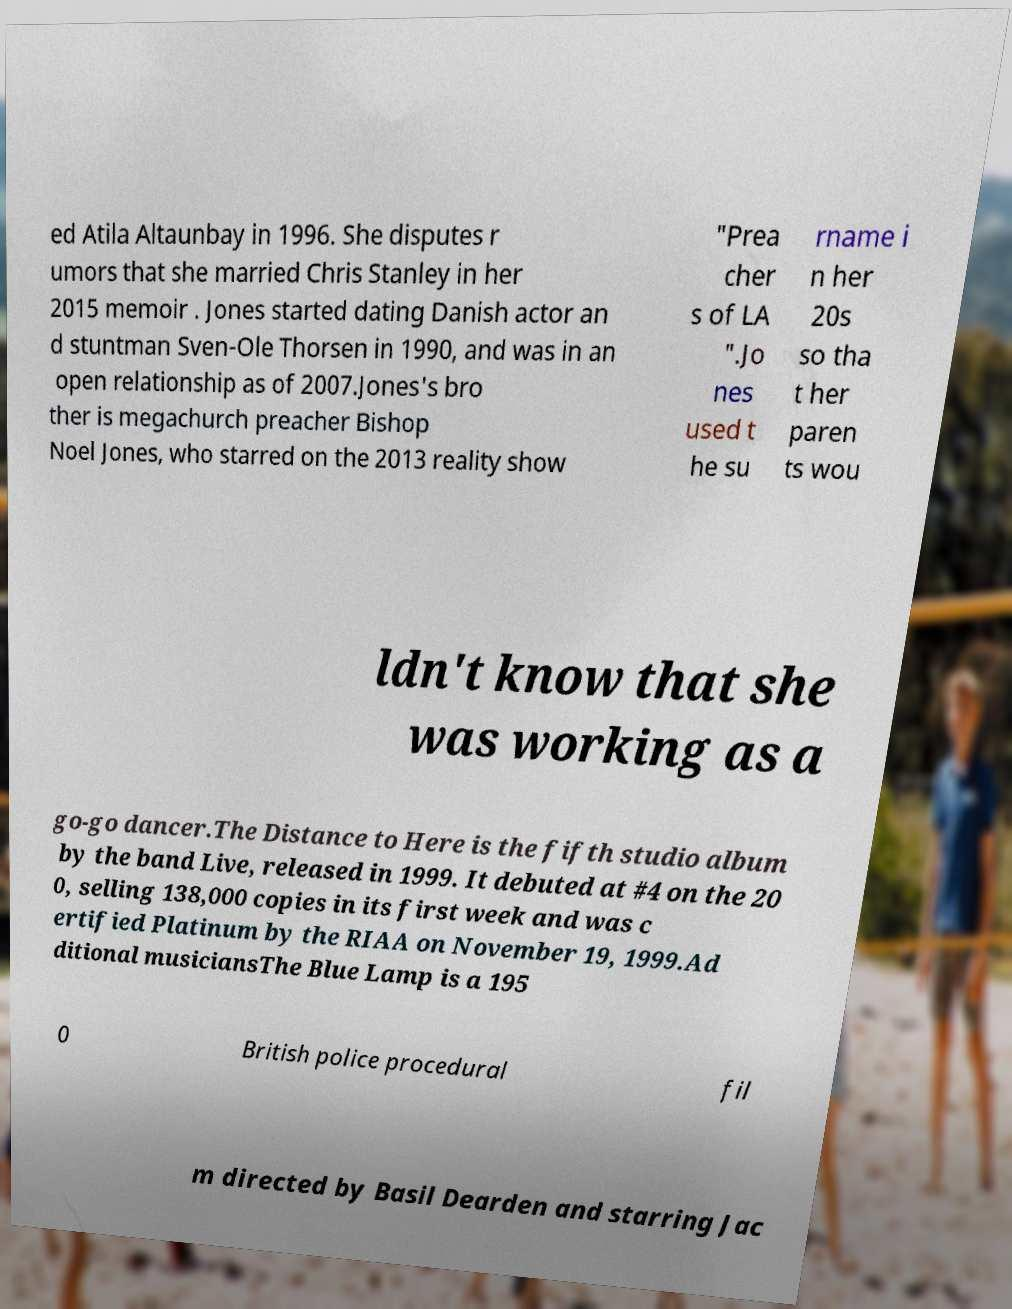Please identify and transcribe the text found in this image. ed Atila Altaunbay in 1996. She disputes r umors that she married Chris Stanley in her 2015 memoir . Jones started dating Danish actor an d stuntman Sven-Ole Thorsen in 1990, and was in an open relationship as of 2007.Jones's bro ther is megachurch preacher Bishop Noel Jones, who starred on the 2013 reality show "Prea cher s of LA ".Jo nes used t he su rname i n her 20s so tha t her paren ts wou ldn't know that she was working as a go-go dancer.The Distance to Here is the fifth studio album by the band Live, released in 1999. It debuted at #4 on the 20 0, selling 138,000 copies in its first week and was c ertified Platinum by the RIAA on November 19, 1999.Ad ditional musiciansThe Blue Lamp is a 195 0 British police procedural fil m directed by Basil Dearden and starring Jac 